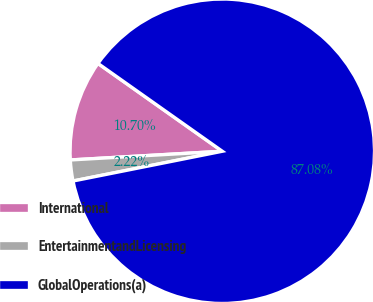Convert chart. <chart><loc_0><loc_0><loc_500><loc_500><pie_chart><fcel>International<fcel>EntertainmentandLicensing<fcel>GlobalOperations(a)<nl><fcel>10.7%<fcel>2.22%<fcel>87.08%<nl></chart> 